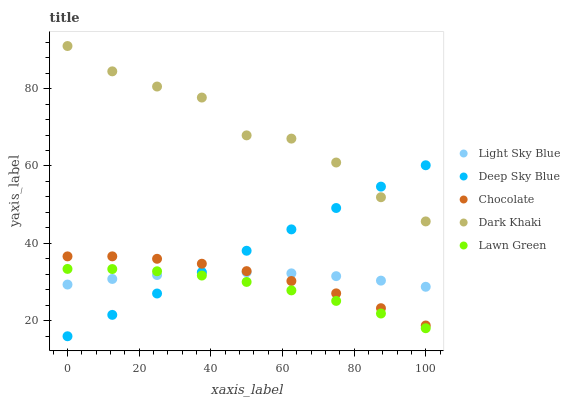Does Lawn Green have the minimum area under the curve?
Answer yes or no. Yes. Does Dark Khaki have the maximum area under the curve?
Answer yes or no. Yes. Does Light Sky Blue have the minimum area under the curve?
Answer yes or no. No. Does Light Sky Blue have the maximum area under the curve?
Answer yes or no. No. Is Deep Sky Blue the smoothest?
Answer yes or no. Yes. Is Dark Khaki the roughest?
Answer yes or no. Yes. Is Lawn Green the smoothest?
Answer yes or no. No. Is Lawn Green the roughest?
Answer yes or no. No. Does Deep Sky Blue have the lowest value?
Answer yes or no. Yes. Does Lawn Green have the lowest value?
Answer yes or no. No. Does Dark Khaki have the highest value?
Answer yes or no. Yes. Does Lawn Green have the highest value?
Answer yes or no. No. Is Light Sky Blue less than Dark Khaki?
Answer yes or no. Yes. Is Dark Khaki greater than Lawn Green?
Answer yes or no. Yes. Does Deep Sky Blue intersect Dark Khaki?
Answer yes or no. Yes. Is Deep Sky Blue less than Dark Khaki?
Answer yes or no. No. Is Deep Sky Blue greater than Dark Khaki?
Answer yes or no. No. Does Light Sky Blue intersect Dark Khaki?
Answer yes or no. No. 